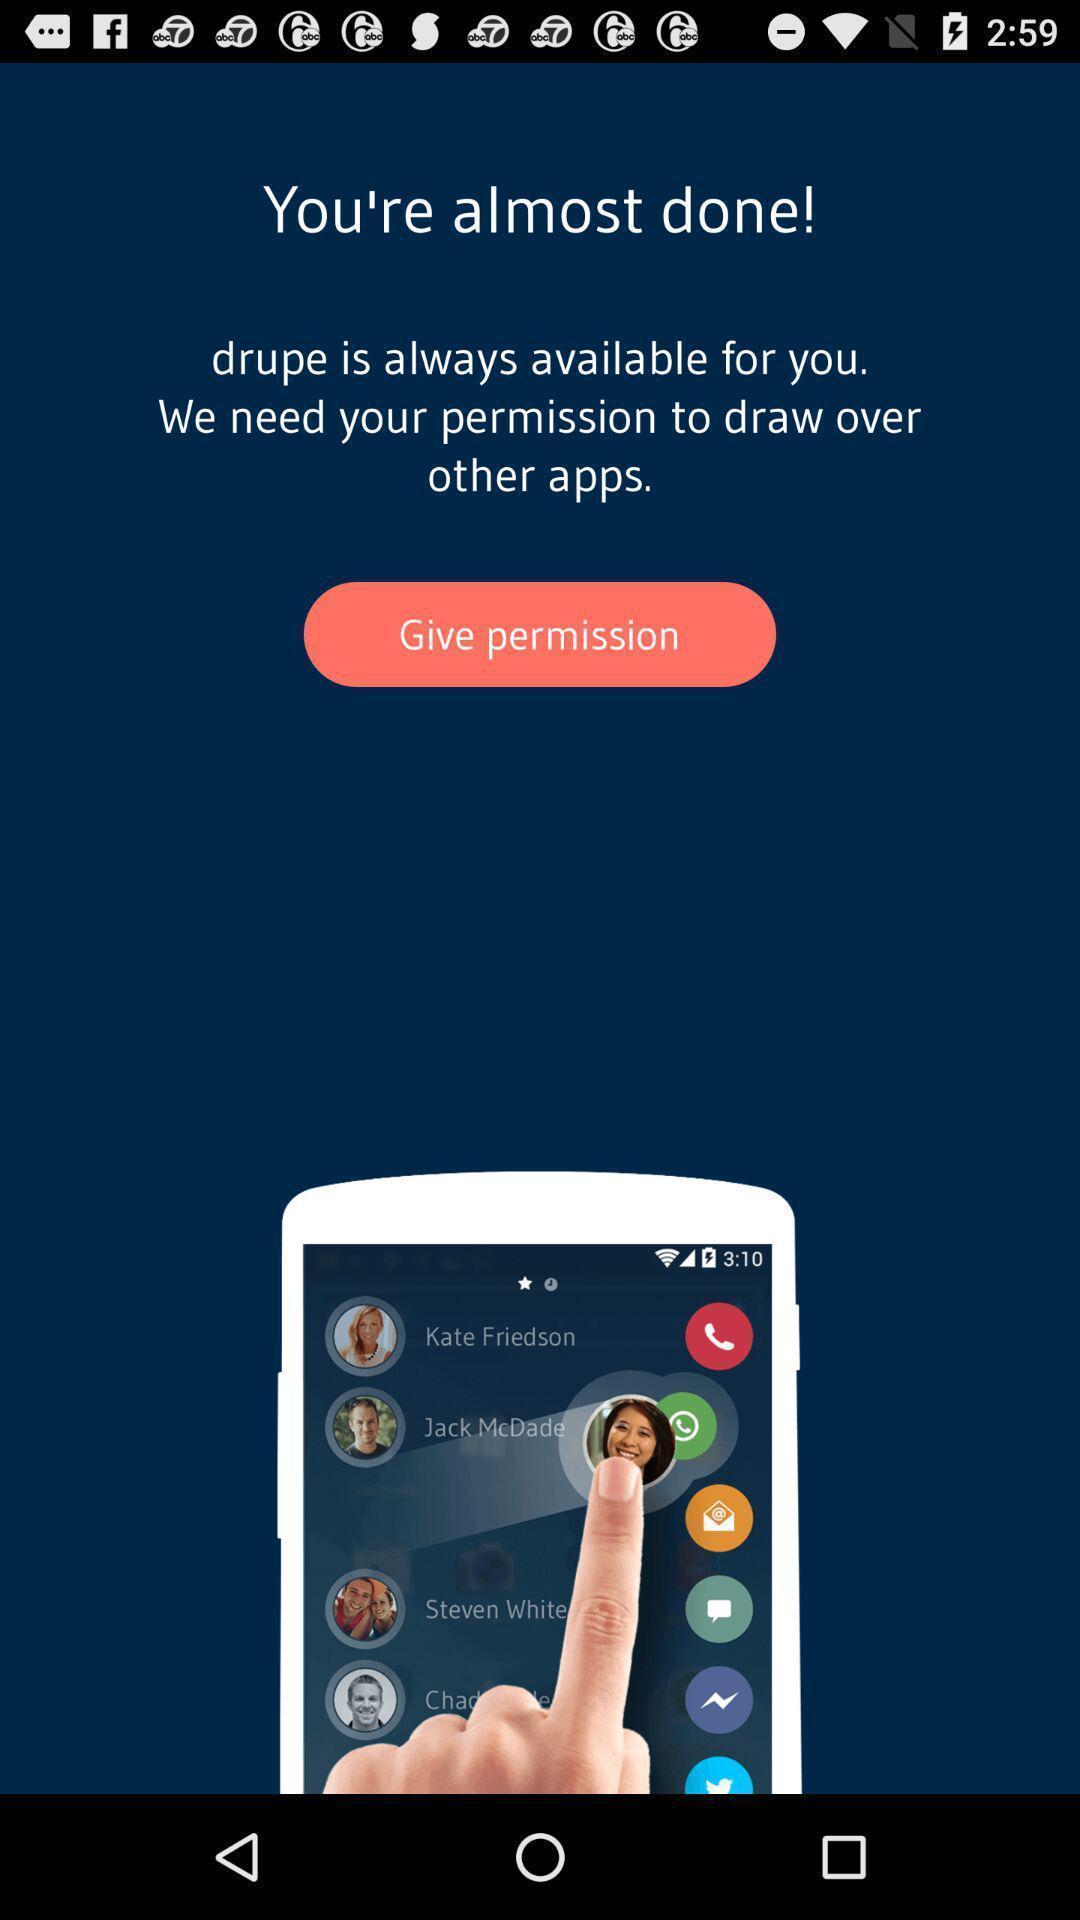Give me a summary of this screen capture. Set-up screen for a caller id based app. 